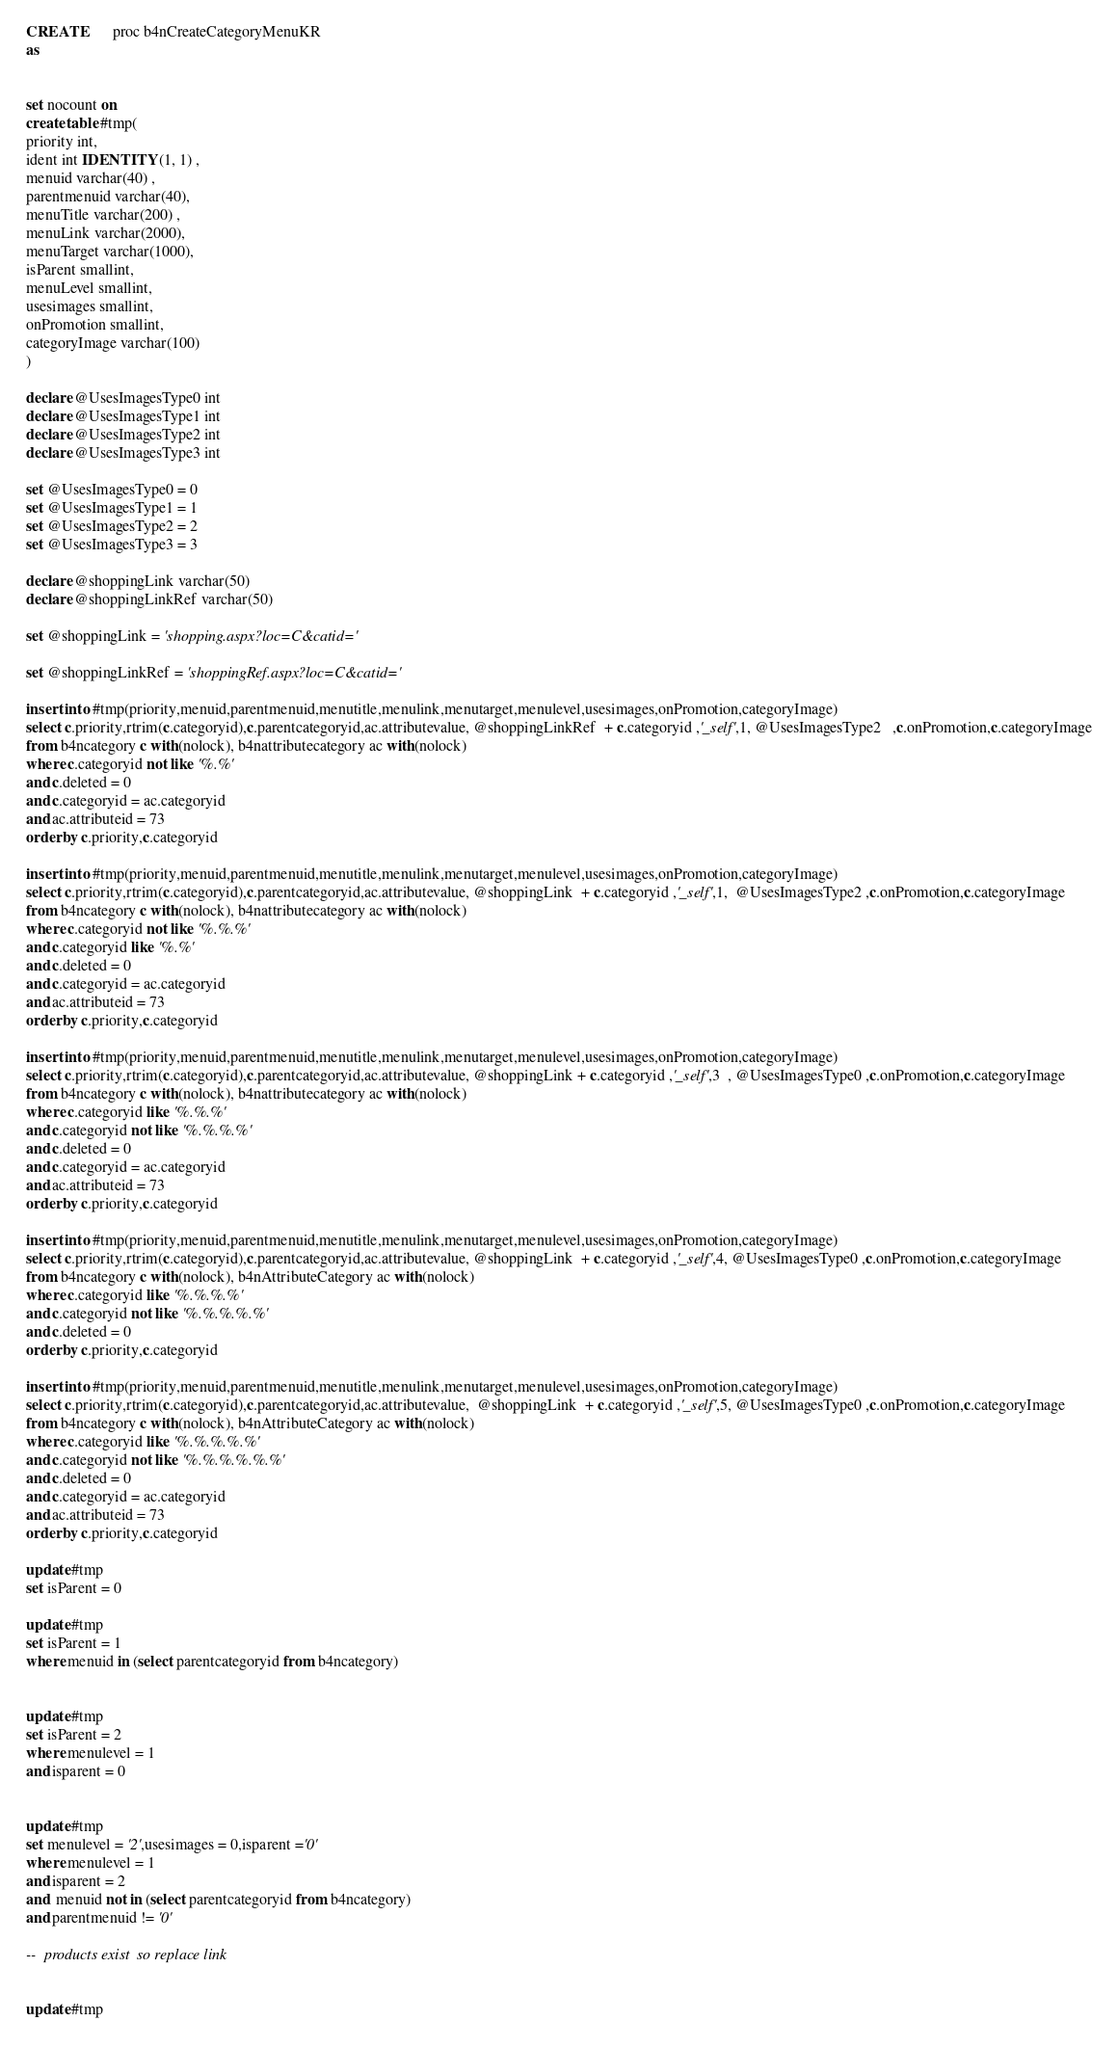<code> <loc_0><loc_0><loc_500><loc_500><_SQL_>




CREATE       proc b4nCreateCategoryMenuKR
as


set nocount on
create table #tmp(
priority int,
ident int IDENTITY (1, 1) ,
menuid varchar(40) ,
parentmenuid varchar(40),
menuTitle varchar(200) ,
menuLink varchar(2000),
menuTarget varchar(1000),
isParent smallint,
menuLevel smallint,
usesimages smallint,
onPromotion smallint,
categoryImage varchar(100)
) 

declare @UsesImagesType0 int
declare @UsesImagesType1 int
declare @UsesImagesType2 int
declare @UsesImagesType3 int

set @UsesImagesType0 = 0
set @UsesImagesType1 = 1
set @UsesImagesType2 = 2
set @UsesImagesType3 = 3

declare @shoppingLink varchar(50)
declare @shoppingLinkRef varchar(50)

set @shoppingLink = 'shopping.aspx?loc=C&catid='

set @shoppingLinkRef = 'shoppingRef.aspx?loc=C&catid='

insert into #tmp(priority,menuid,parentmenuid,menutitle,menulink,menutarget,menulevel,usesimages,onPromotion,categoryImage)
select c.priority,rtrim(c.categoryid),c.parentcategoryid,ac.attributevalue, @shoppingLinkRef  + c.categoryid ,'_self',1, @UsesImagesType2   ,c.onPromotion,c.categoryImage
from b4ncategory c with(nolock), b4nattributecategory ac with(nolock)
where c.categoryid not like '%.%'
and c.deleted = 0
and c.categoryid = ac.categoryid
and ac.attributeid = 73
order by c.priority,c.categoryid

insert into #tmp(priority,menuid,parentmenuid,menutitle,menulink,menutarget,menulevel,usesimages,onPromotion,categoryImage)
select c.priority,rtrim(c.categoryid),c.parentcategoryid,ac.attributevalue, @shoppingLink  + c.categoryid ,'_self',1,  @UsesImagesType2 ,c.onPromotion,c.categoryImage
from b4ncategory c with(nolock), b4nattributecategory ac with(nolock)
where c.categoryid not like '%.%.%'
and c.categoryid like '%.%'
and c.deleted = 0
and c.categoryid = ac.categoryid
and ac.attributeid = 73
order by c.priority,c.categoryid

insert into #tmp(priority,menuid,parentmenuid,menutitle,menulink,menutarget,menulevel,usesimages,onPromotion,categoryImage)
select c.priority,rtrim(c.categoryid),c.parentcategoryid,ac.attributevalue, @shoppingLink + c.categoryid ,'_self',3  , @UsesImagesType0 ,c.onPromotion,c.categoryImage
from b4ncategory c with(nolock), b4nattributecategory ac with(nolock)
where c.categoryid like '%.%.%'
and c.categoryid not like '%.%.%.%'
and c.deleted = 0
and c.categoryid = ac.categoryid
and ac.attributeid = 73
order by c.priority,c.categoryid

insert into #tmp(priority,menuid,parentmenuid,menutitle,menulink,menutarget,menulevel,usesimages,onPromotion,categoryImage)
select c.priority,rtrim(c.categoryid),c.parentcategoryid,ac.attributevalue, @shoppingLink  + c.categoryid ,'_self',4, @UsesImagesType0 ,c.onPromotion,c.categoryImage
from b4ncategory c with(nolock), b4nAttributeCategory ac with(nolock)
where c.categoryid like '%.%.%.%'
and c.categoryid not like '%.%.%.%.%'
and c.deleted = 0
order by c.priority,c.categoryid

insert into #tmp(priority,menuid,parentmenuid,menutitle,menulink,menutarget,menulevel,usesimages,onPromotion,categoryImage)
select c.priority,rtrim(c.categoryid),c.parentcategoryid,ac.attributevalue,  @shoppingLink  + c.categoryid ,'_self',5, @UsesImagesType0 ,c.onPromotion,c.categoryImage
from b4ncategory c with(nolock), b4nAttributeCategory ac with(nolock)
where c.categoryid like '%.%.%.%.%'
and c.categoryid not like '%.%.%.%.%.%'
and c.deleted = 0
and c.categoryid = ac.categoryid
and ac.attributeid = 73
order by c.priority,c.categoryid

update #tmp
set isParent = 0

update #tmp
set isParent = 1
where menuid in (select parentcategoryid from b4ncategory)


update #tmp
set isParent = 2
where menulevel = 1
and isparent = 0


update #tmp
set menulevel = '2',usesimages = 0,isparent ='0'
where menulevel = 1
and isparent = 2
and  menuid not in (select parentcategoryid from b4ncategory)
and parentmenuid != '0'

--  products exist  so replace link

update #tmp</code> 